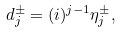Convert formula to latex. <formula><loc_0><loc_0><loc_500><loc_500>d _ { j } ^ { \pm } = ( i ) ^ { j - 1 } \eta _ { j } ^ { \pm } ,</formula> 